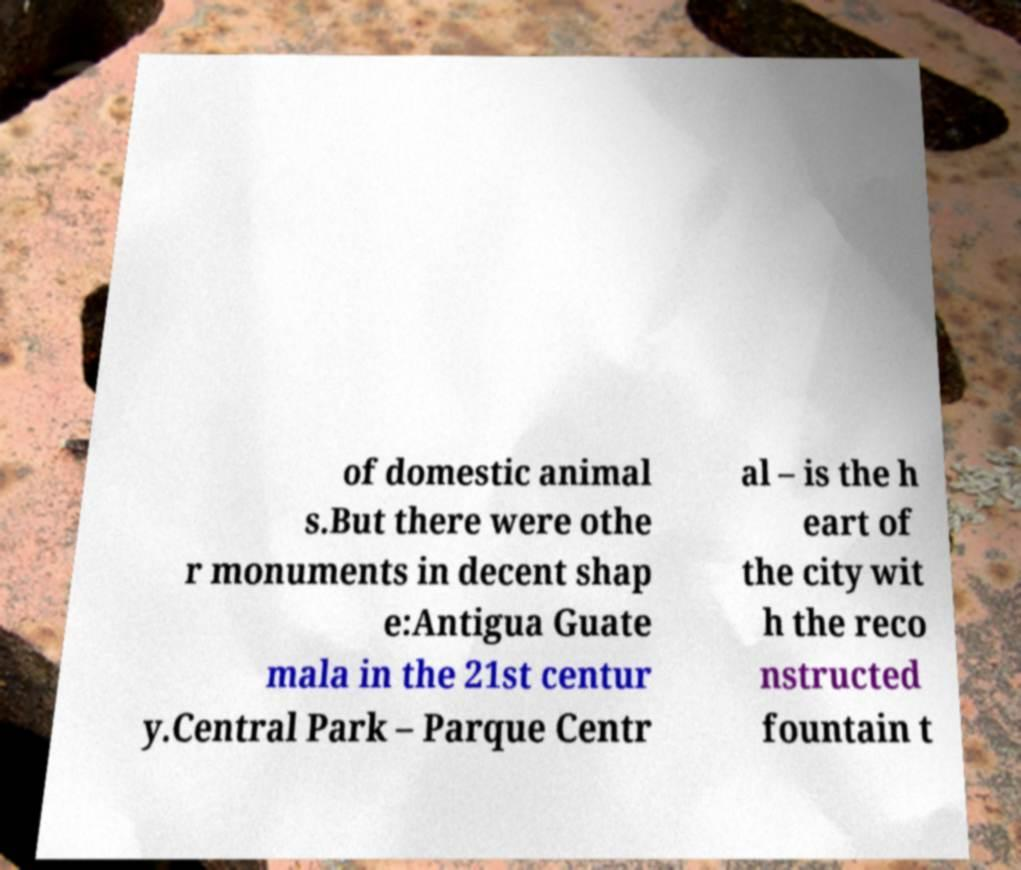I need the written content from this picture converted into text. Can you do that? of domestic animal s.But there were othe r monuments in decent shap e:Antigua Guate mala in the 21st centur y.Central Park – Parque Centr al – is the h eart of the city wit h the reco nstructed fountain t 